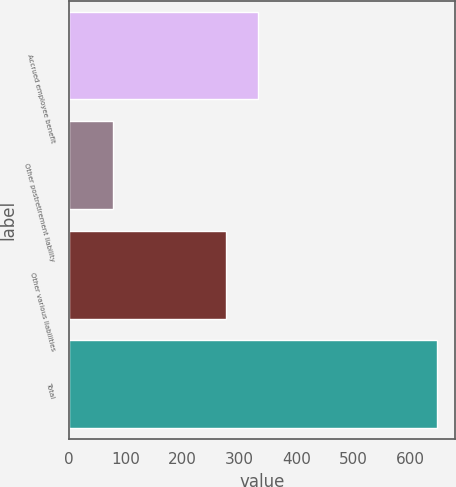Convert chart to OTSL. <chart><loc_0><loc_0><loc_500><loc_500><bar_chart><fcel>Accrued employee benefit<fcel>Other postretirement liability<fcel>Other various liabilities<fcel>Total<nl><fcel>332.97<fcel>77.3<fcel>276.1<fcel>646<nl></chart> 